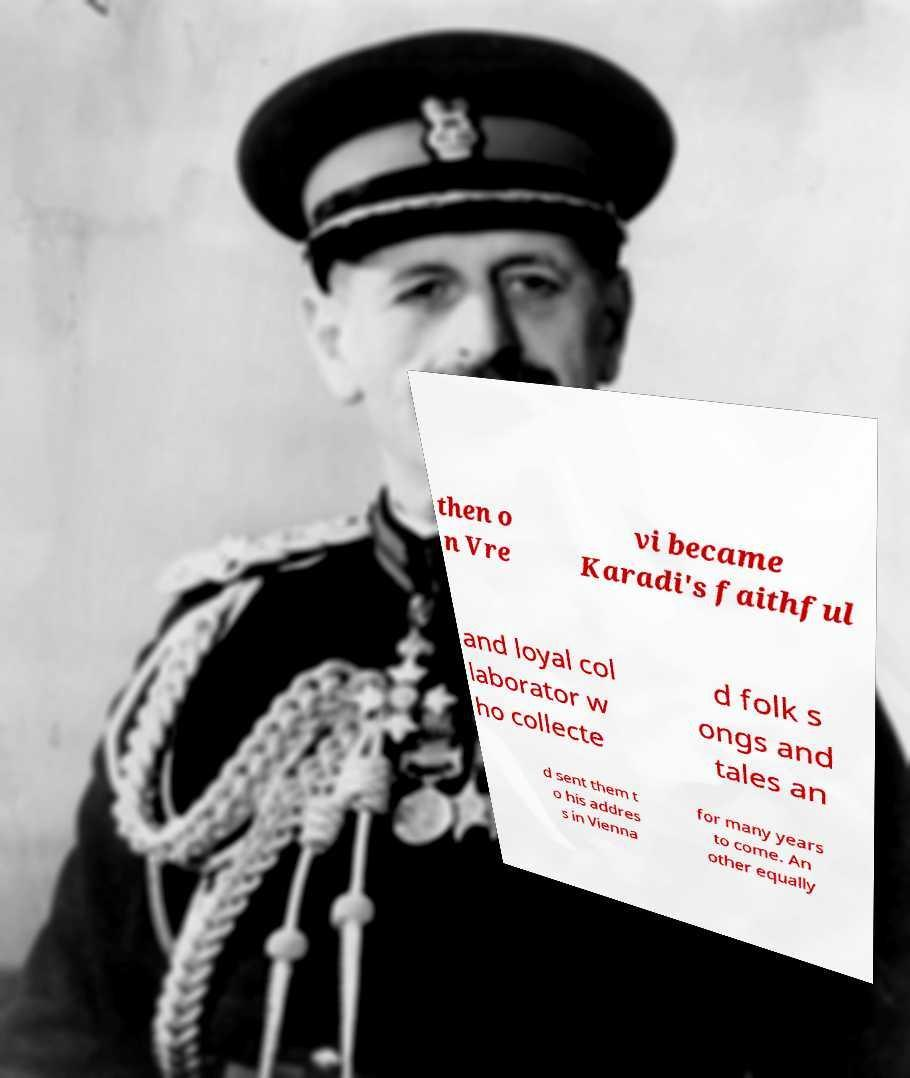There's text embedded in this image that I need extracted. Can you transcribe it verbatim? then o n Vre vi became Karadi's faithful and loyal col laborator w ho collecte d folk s ongs and tales an d sent them t o his addres s in Vienna for many years to come. An other equally 